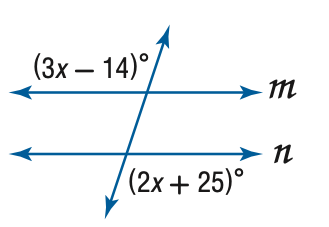Question: Find x so that m \parallel n.
Choices:
A. 11
B. 38.2
C. 39
D. 103
Answer with the letter. Answer: C 